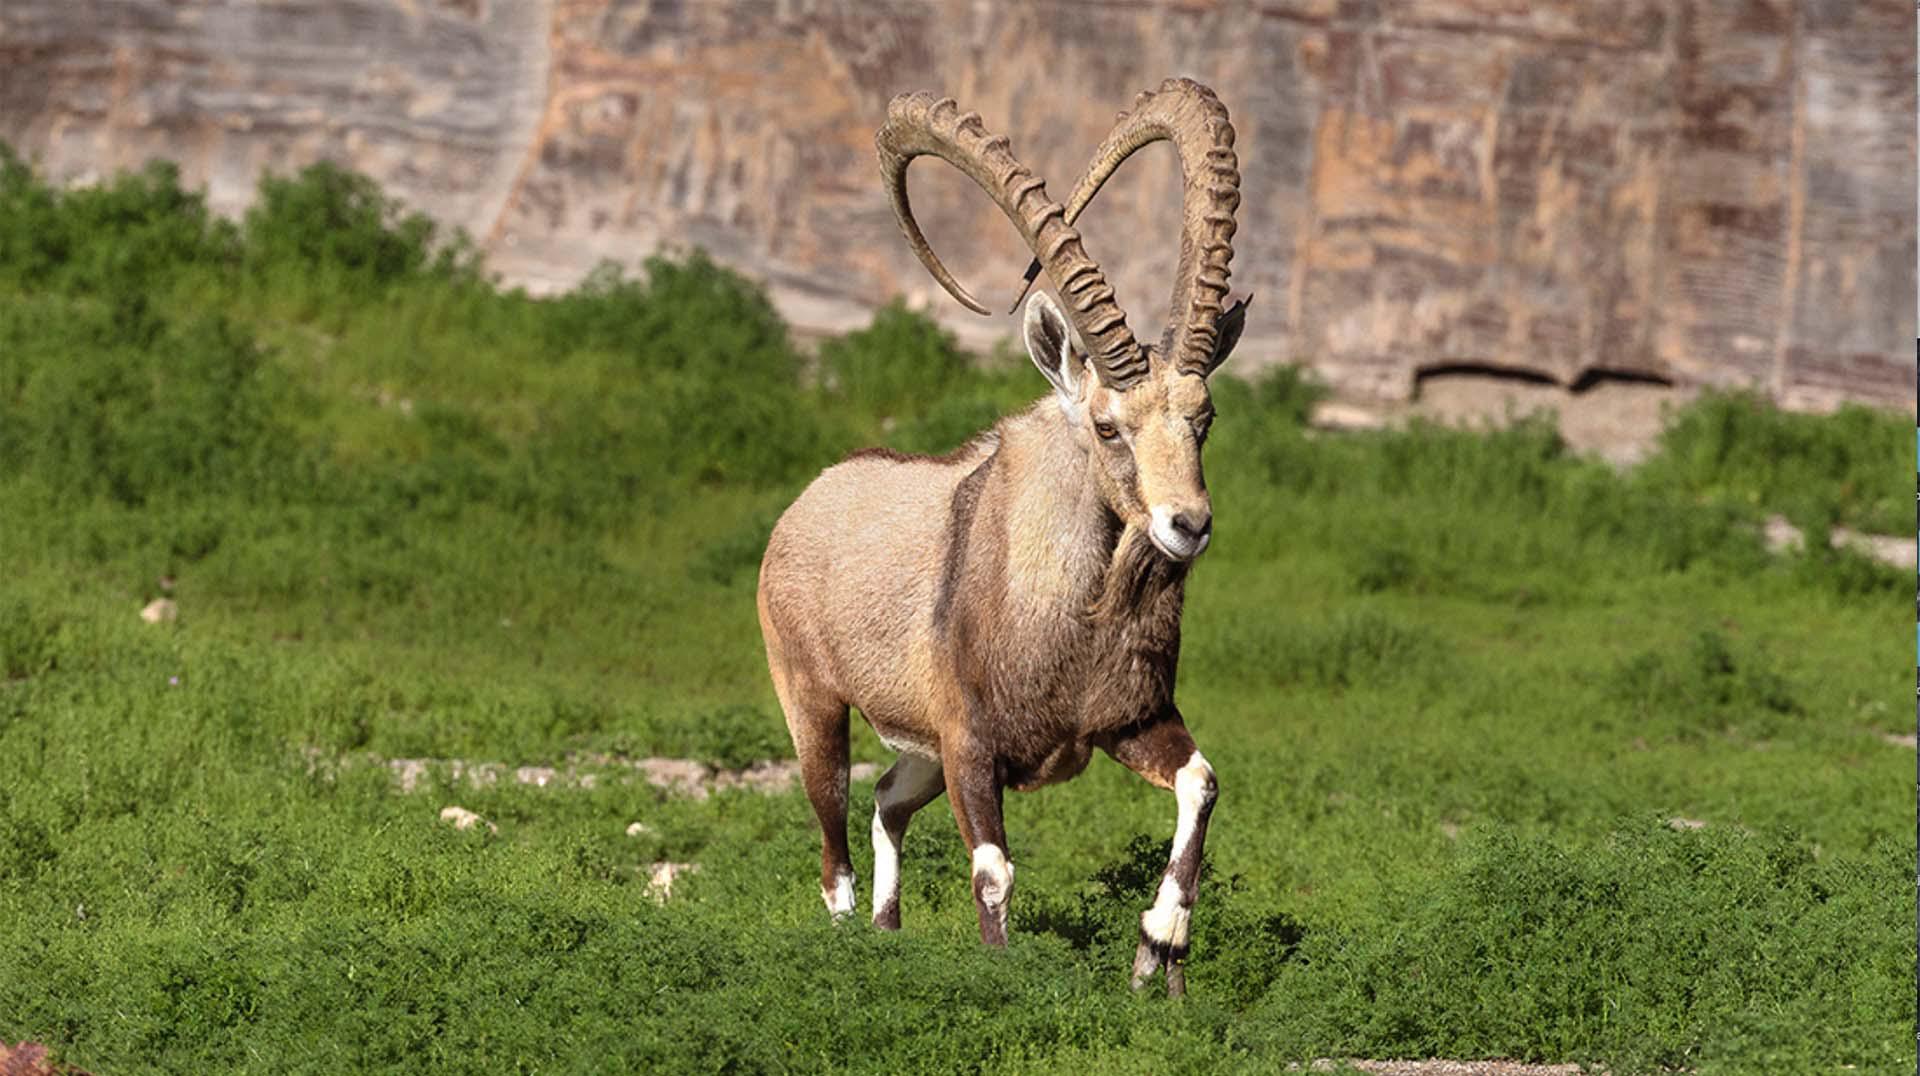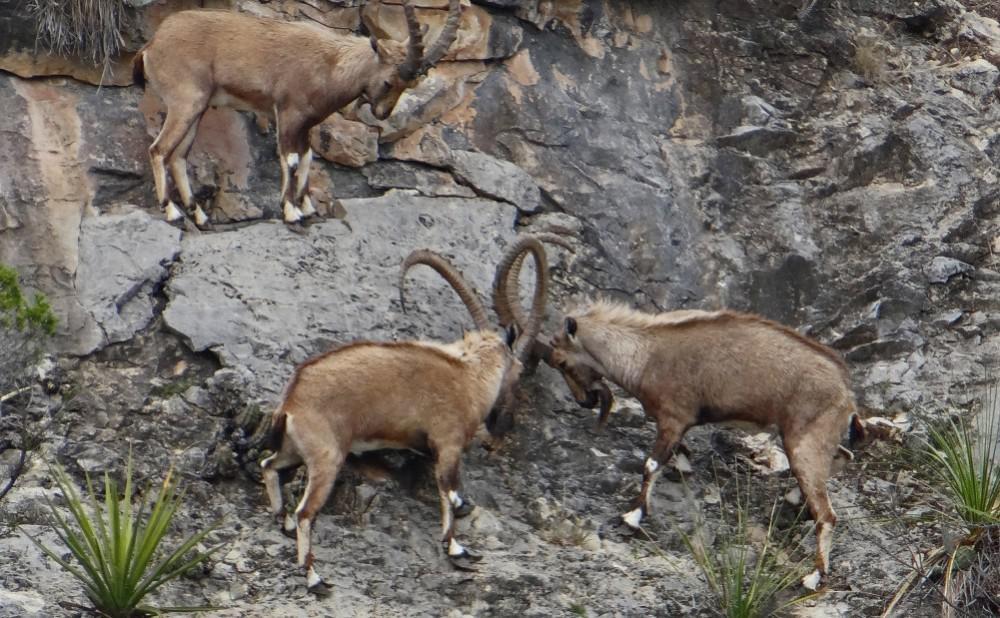The first image is the image on the left, the second image is the image on the right. Assess this claim about the two images: "An image shows three horned animals on a surface with flat stones arranged in a row.". Correct or not? Answer yes or no. No. The first image is the image on the left, the second image is the image on the right. Examine the images to the left and right. Is the description "At least one of the animals is standing in a grassy area." accurate? Answer yes or no. Yes. 